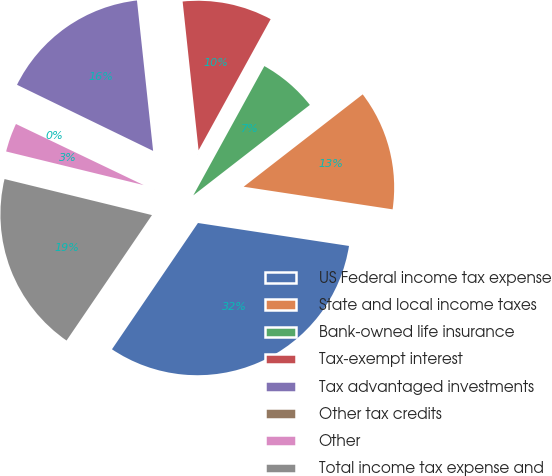Convert chart to OTSL. <chart><loc_0><loc_0><loc_500><loc_500><pie_chart><fcel>US Federal income tax expense<fcel>State and local income taxes<fcel>Bank-owned life insurance<fcel>Tax-exempt interest<fcel>Tax advantaged investments<fcel>Other tax credits<fcel>Other<fcel>Total income tax expense and<nl><fcel>32.11%<fcel>12.9%<fcel>6.5%<fcel>9.7%<fcel>16.1%<fcel>0.09%<fcel>3.29%<fcel>19.3%<nl></chart> 